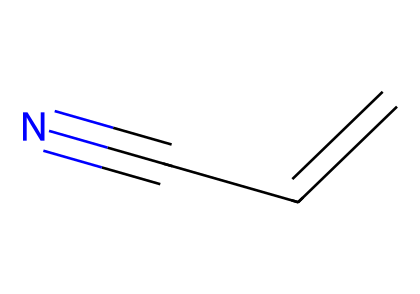What is the molecular formula of this compound? The SMILES representation C=CC#N indicates that the compound consists of three carbon atoms (C), three hydrogen atoms (H), and one nitrogen atom (N). Thus, the molecular formula derived from this information is C3H3N.
Answer: C3H3N How many double bonds are present in this chemical? The presence of the "C=C" in the SMILES indicates one double bond between the first and second carbon atoms. There are no additional double bonds present in the remaining structure.
Answer: 1 What type of functional group is present in acrylonitrile? The "#N" in the SMILES indicates the presence of a nitrile group, characterized by a carbon triple-bonded to a nitrogen atom. Therefore, the functional group identified is a nitrile.
Answer: nitrile What is the significance of the triple bond in nitriles like acrylonitrile? The triple bond between the carbon and nitrogen contributes to the reactivity and stability of acrylonitrile, affecting its polymerization properties, making it suitable for producing durable materials.
Answer: reactivity What is the total number of hydrogen atoms attached to the carbons in this compound? Analyzing the structure, two hydrogen atoms are attached to the first carbon, one hydrogen to the second, and no hydrogen to the terminal carbon that is attached to the nitrogen in the triple bond. Therefore, the total is three hydrogen atoms.
Answer: 3 What physical state is acrylonitrile typically found in? Acrylonitrile is known to be a colorless liquid at room temperature, indicating its common physical state under standard conditions.
Answer: liquid 